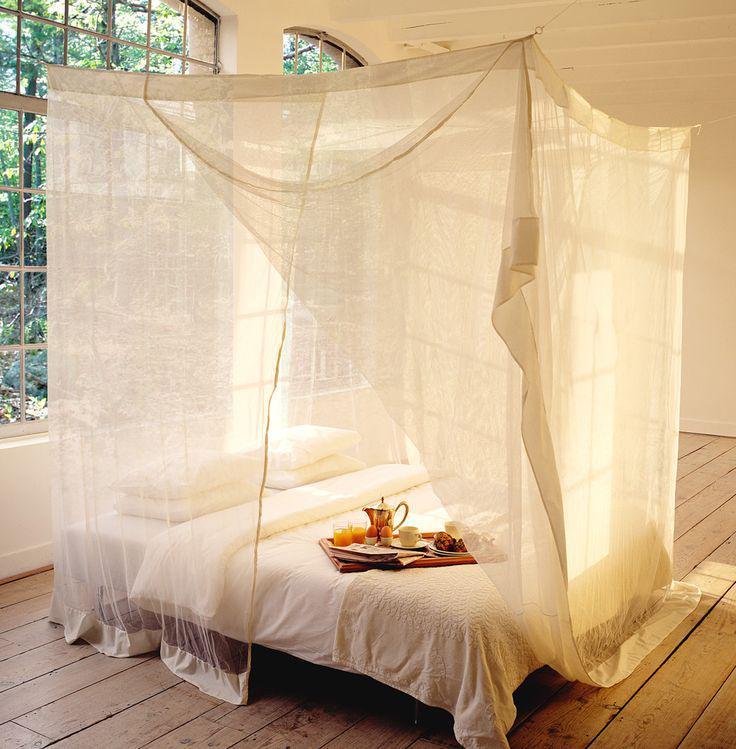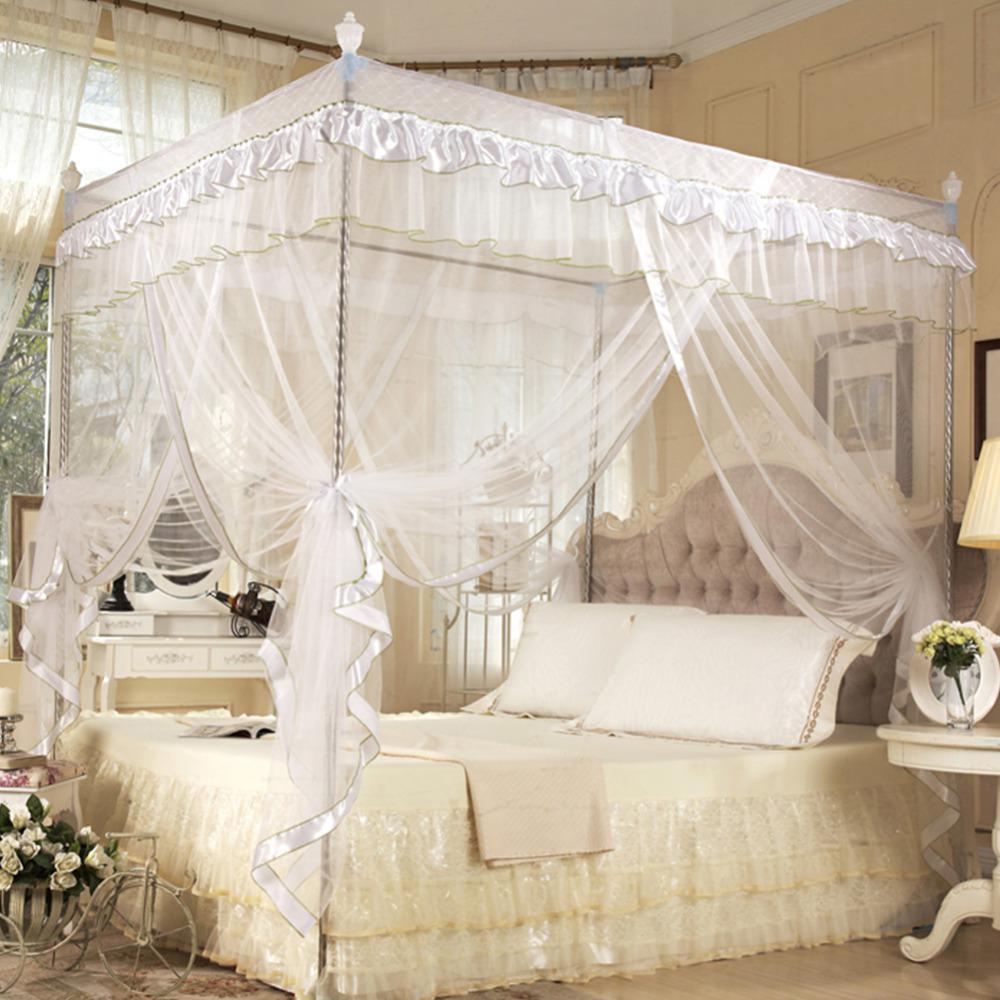The first image is the image on the left, the second image is the image on the right. Considering the images on both sides, is "The bedposts in one image have a draping that is lavender." valid? Answer yes or no. No. The first image is the image on the left, the second image is the image on the right. Given the left and right images, does the statement "An image shows a four-posted bed decorated with a curtain-tied lavender canopy." hold true? Answer yes or no. No. 